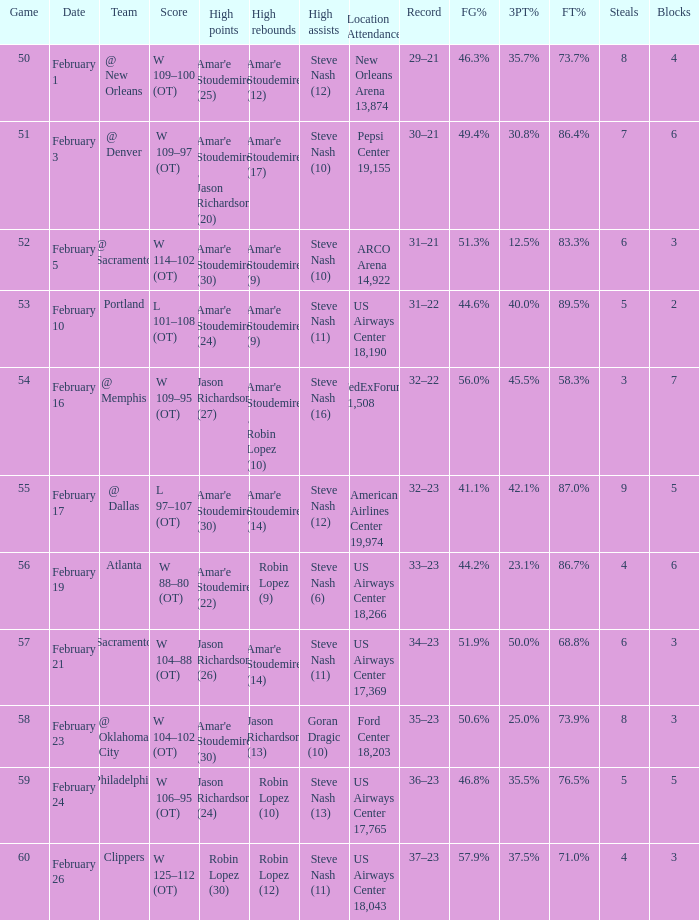Name the date for score w 109–95 (ot) February 16. 